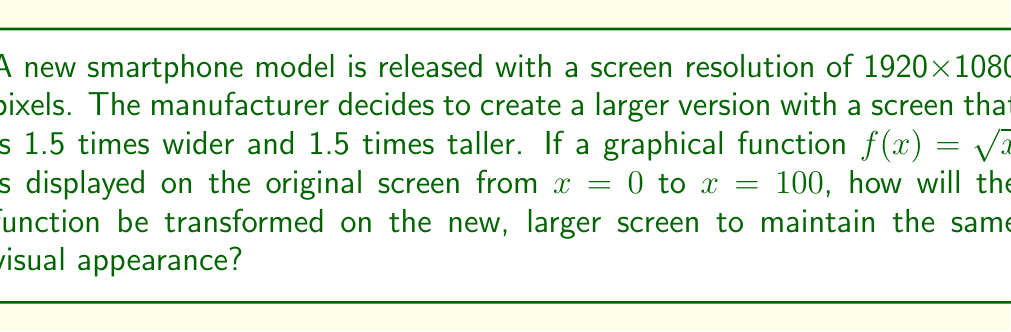What is the answer to this math problem? To solve this problem, we need to consider how the change in screen dimensions affects the graph of the function. Let's approach this step-by-step:

1) The original function is $f(x)=\sqrt{x}$ displayed from $x=0$ to $x=100$ on a 1920x1080 pixel screen.

2) The new screen is 1.5 times wider and 1.5 times taller. This means that to maintain the same visual appearance, we need to stretch the function both horizontally and vertically by a factor of 1.5.

3) To stretch a function horizontally by a factor of $k$, we replace $x$ with $\frac{x}{k}$. In this case, $k=1.5$, so we replace $x$ with $\frac{x}{1.5}$.

4) To stretch a function vertically by a factor of $k$, we multiply the entire function by $k$. In this case, we multiply by 1.5.

5) Applying both transformations, our new function becomes:

   $g(x) = 1.5 \cdot f(\frac{x}{1.5}) = 1.5 \cdot \sqrt{\frac{x}{1.5}}$

6) Simplifying:
   
   $g(x) = 1.5 \cdot \sqrt{\frac{x}{1.5}} = 1.5 \cdot \frac{1}{\sqrt{1.5}} \cdot \sqrt{x} = \sqrt{1.5} \cdot \sqrt{x}$

7) The domain of the function will also be stretched. The original domain was from 0 to 100. On the new screen, it will be from 0 to $100 \cdot 1.5 = 150$.

Therefore, the transformed function $g(x) = \sqrt{1.5} \cdot \sqrt{x}$ displayed from $x=0$ to $x=150$ will maintain the same visual appearance on the larger screen as $f(x)=\sqrt{x}$ did on the original screen.
Answer: The transformed function is $g(x) = \sqrt{1.5} \cdot \sqrt{x}$, displayed from $x=0$ to $x=150$. 